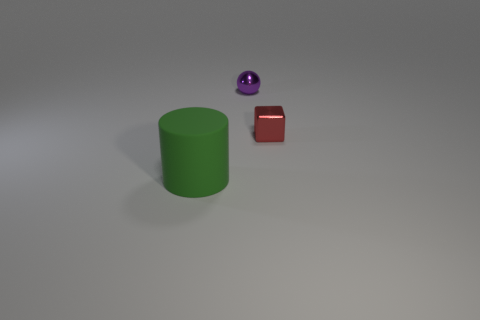Is there any other thing that has the same material as the green cylinder?
Keep it short and to the point. No. What number of red shiny things are the same shape as the tiny purple metallic object?
Your response must be concise. 0. Is the color of the thing that is in front of the red shiny cube the same as the tiny shiny block that is in front of the purple shiny sphere?
Your answer should be very brief. No. What material is the block that is the same size as the sphere?
Offer a terse response. Metal. Are there any red shiny cubes of the same size as the purple ball?
Offer a terse response. Yes. Are there fewer big cylinders to the left of the green rubber object than green objects?
Give a very brief answer. Yes. Are there fewer tiny red metallic cubes in front of the large green rubber object than cubes to the left of the purple metallic object?
Your answer should be very brief. No. What number of cubes are either large rubber things or small red things?
Ensure brevity in your answer.  1. Do the small object to the right of the small shiny sphere and the thing in front of the tiny red cube have the same material?
Provide a succinct answer. No. There is a thing that is the same size as the cube; what shape is it?
Your response must be concise. Sphere. 